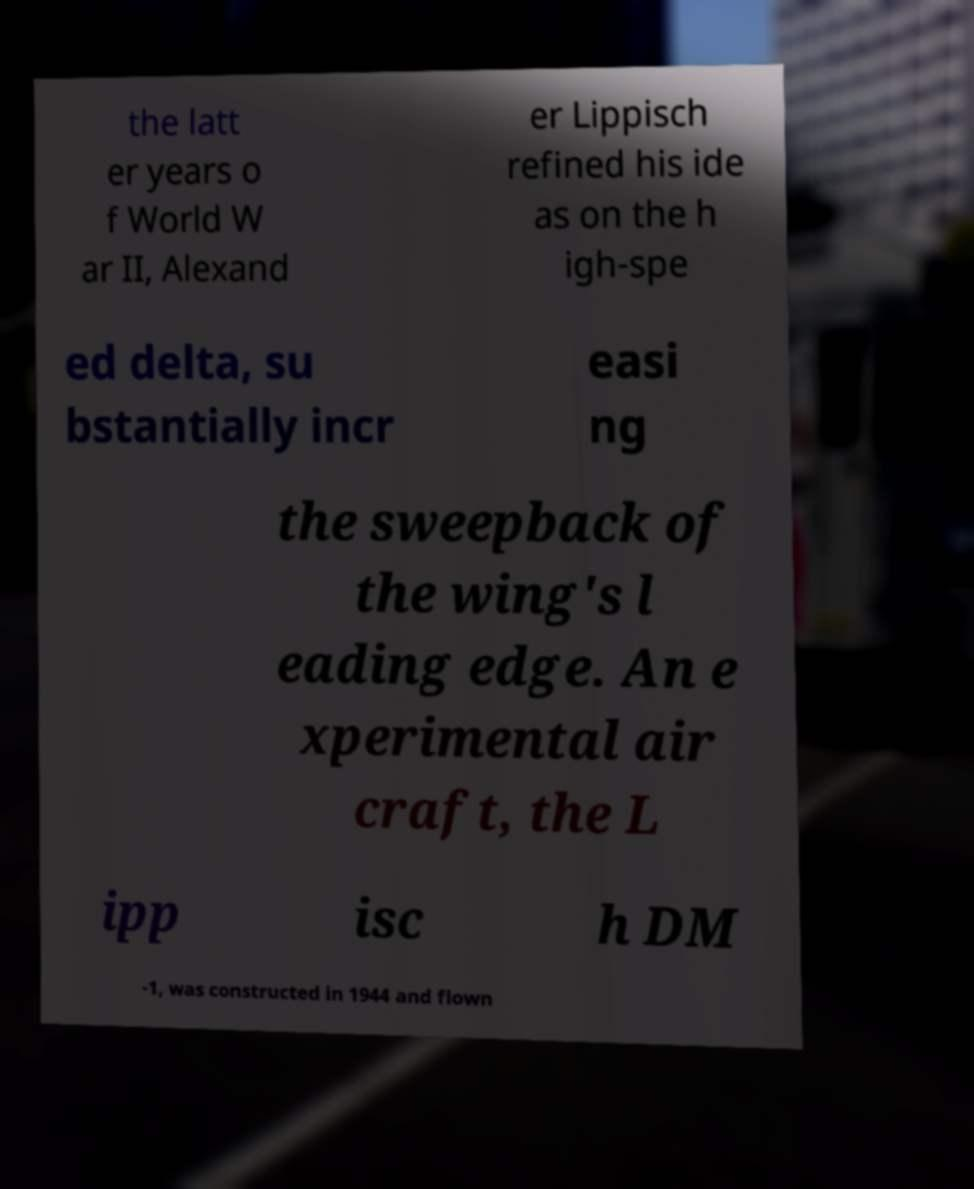Can you read and provide the text displayed in the image?This photo seems to have some interesting text. Can you extract and type it out for me? the latt er years o f World W ar II, Alexand er Lippisch refined his ide as on the h igh-spe ed delta, su bstantially incr easi ng the sweepback of the wing's l eading edge. An e xperimental air craft, the L ipp isc h DM -1, was constructed in 1944 and flown 